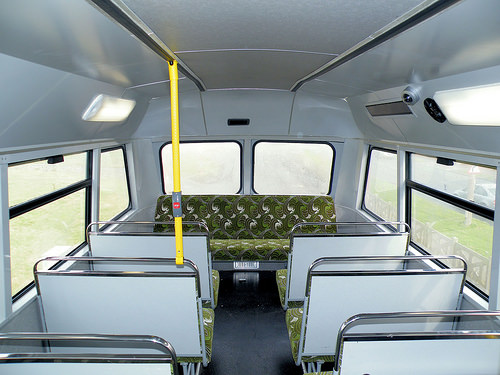<image>
Can you confirm if the bar is to the right of the light? Yes. From this viewpoint, the bar is positioned to the right side relative to the light. 